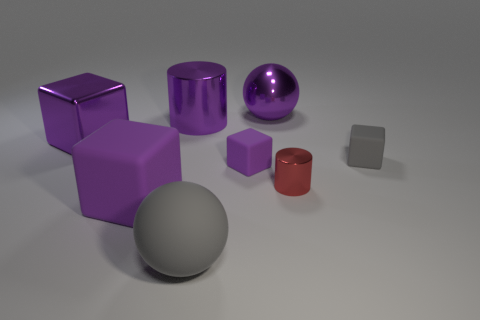There is a large metal thing in front of the cylinder that is left of the rubber sphere; what is its shape?
Your answer should be very brief. Cube. The tiny red shiny object has what shape?
Keep it short and to the point. Cylinder. The purple object that is both left of the small purple rubber block and in front of the purple metallic block has what shape?
Your response must be concise. Cube. What is the color of the big block that is the same material as the gray ball?
Make the answer very short. Purple. What is the shape of the big purple metal object that is left of the large purple cylinder to the right of the thing to the left of the big matte block?
Keep it short and to the point. Cube. The purple metallic cylinder is what size?
Provide a short and direct response. Large. There is a tiny red object that is made of the same material as the large cylinder; what shape is it?
Give a very brief answer. Cylinder. Are there fewer big purple rubber cubes that are to the right of the big purple cylinder than tiny red matte cylinders?
Your answer should be very brief. No. There is a large rubber block behind the matte sphere; what color is it?
Your answer should be compact. Purple. There is a tiny block that is the same color as the matte ball; what is its material?
Offer a very short reply. Rubber. 